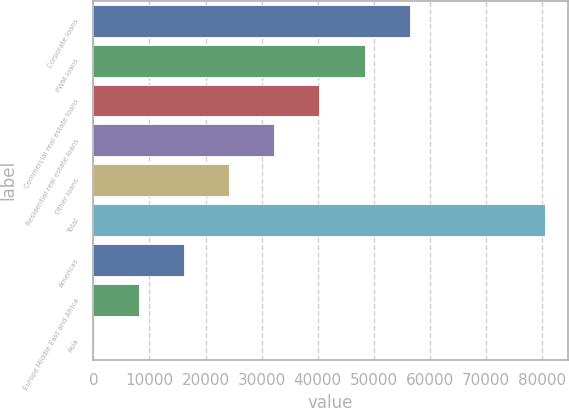Convert chart to OTSL. <chart><loc_0><loc_0><loc_500><loc_500><bar_chart><fcel>Corporate loans<fcel>PWM loans<fcel>Commercial real estate loans<fcel>Residential real estate loans<fcel>Other loans<fcel>Total<fcel>Americas<fcel>Europe Middle East and Africa<fcel>Asia<nl><fcel>56413.9<fcel>48355.2<fcel>40296.5<fcel>32237.8<fcel>24179.1<fcel>80590<fcel>16120.4<fcel>8061.7<fcel>3<nl></chart> 